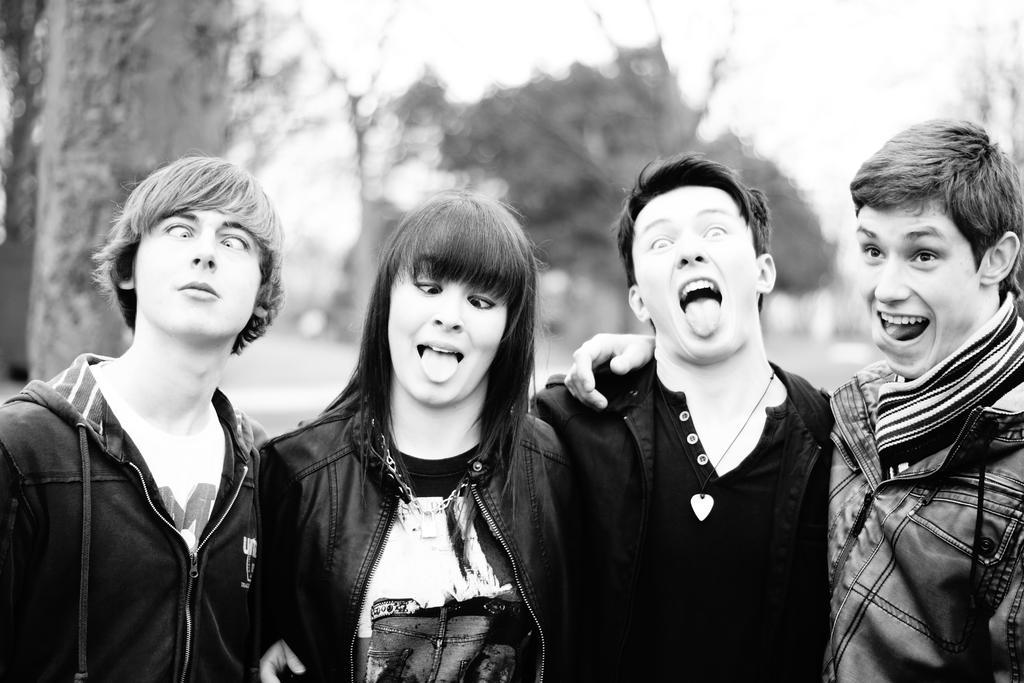Could you give a brief overview of what you see in this image? In the image we can see there are four people wearing clothes, this is a neck chain and a jacket. The background is blurred. 